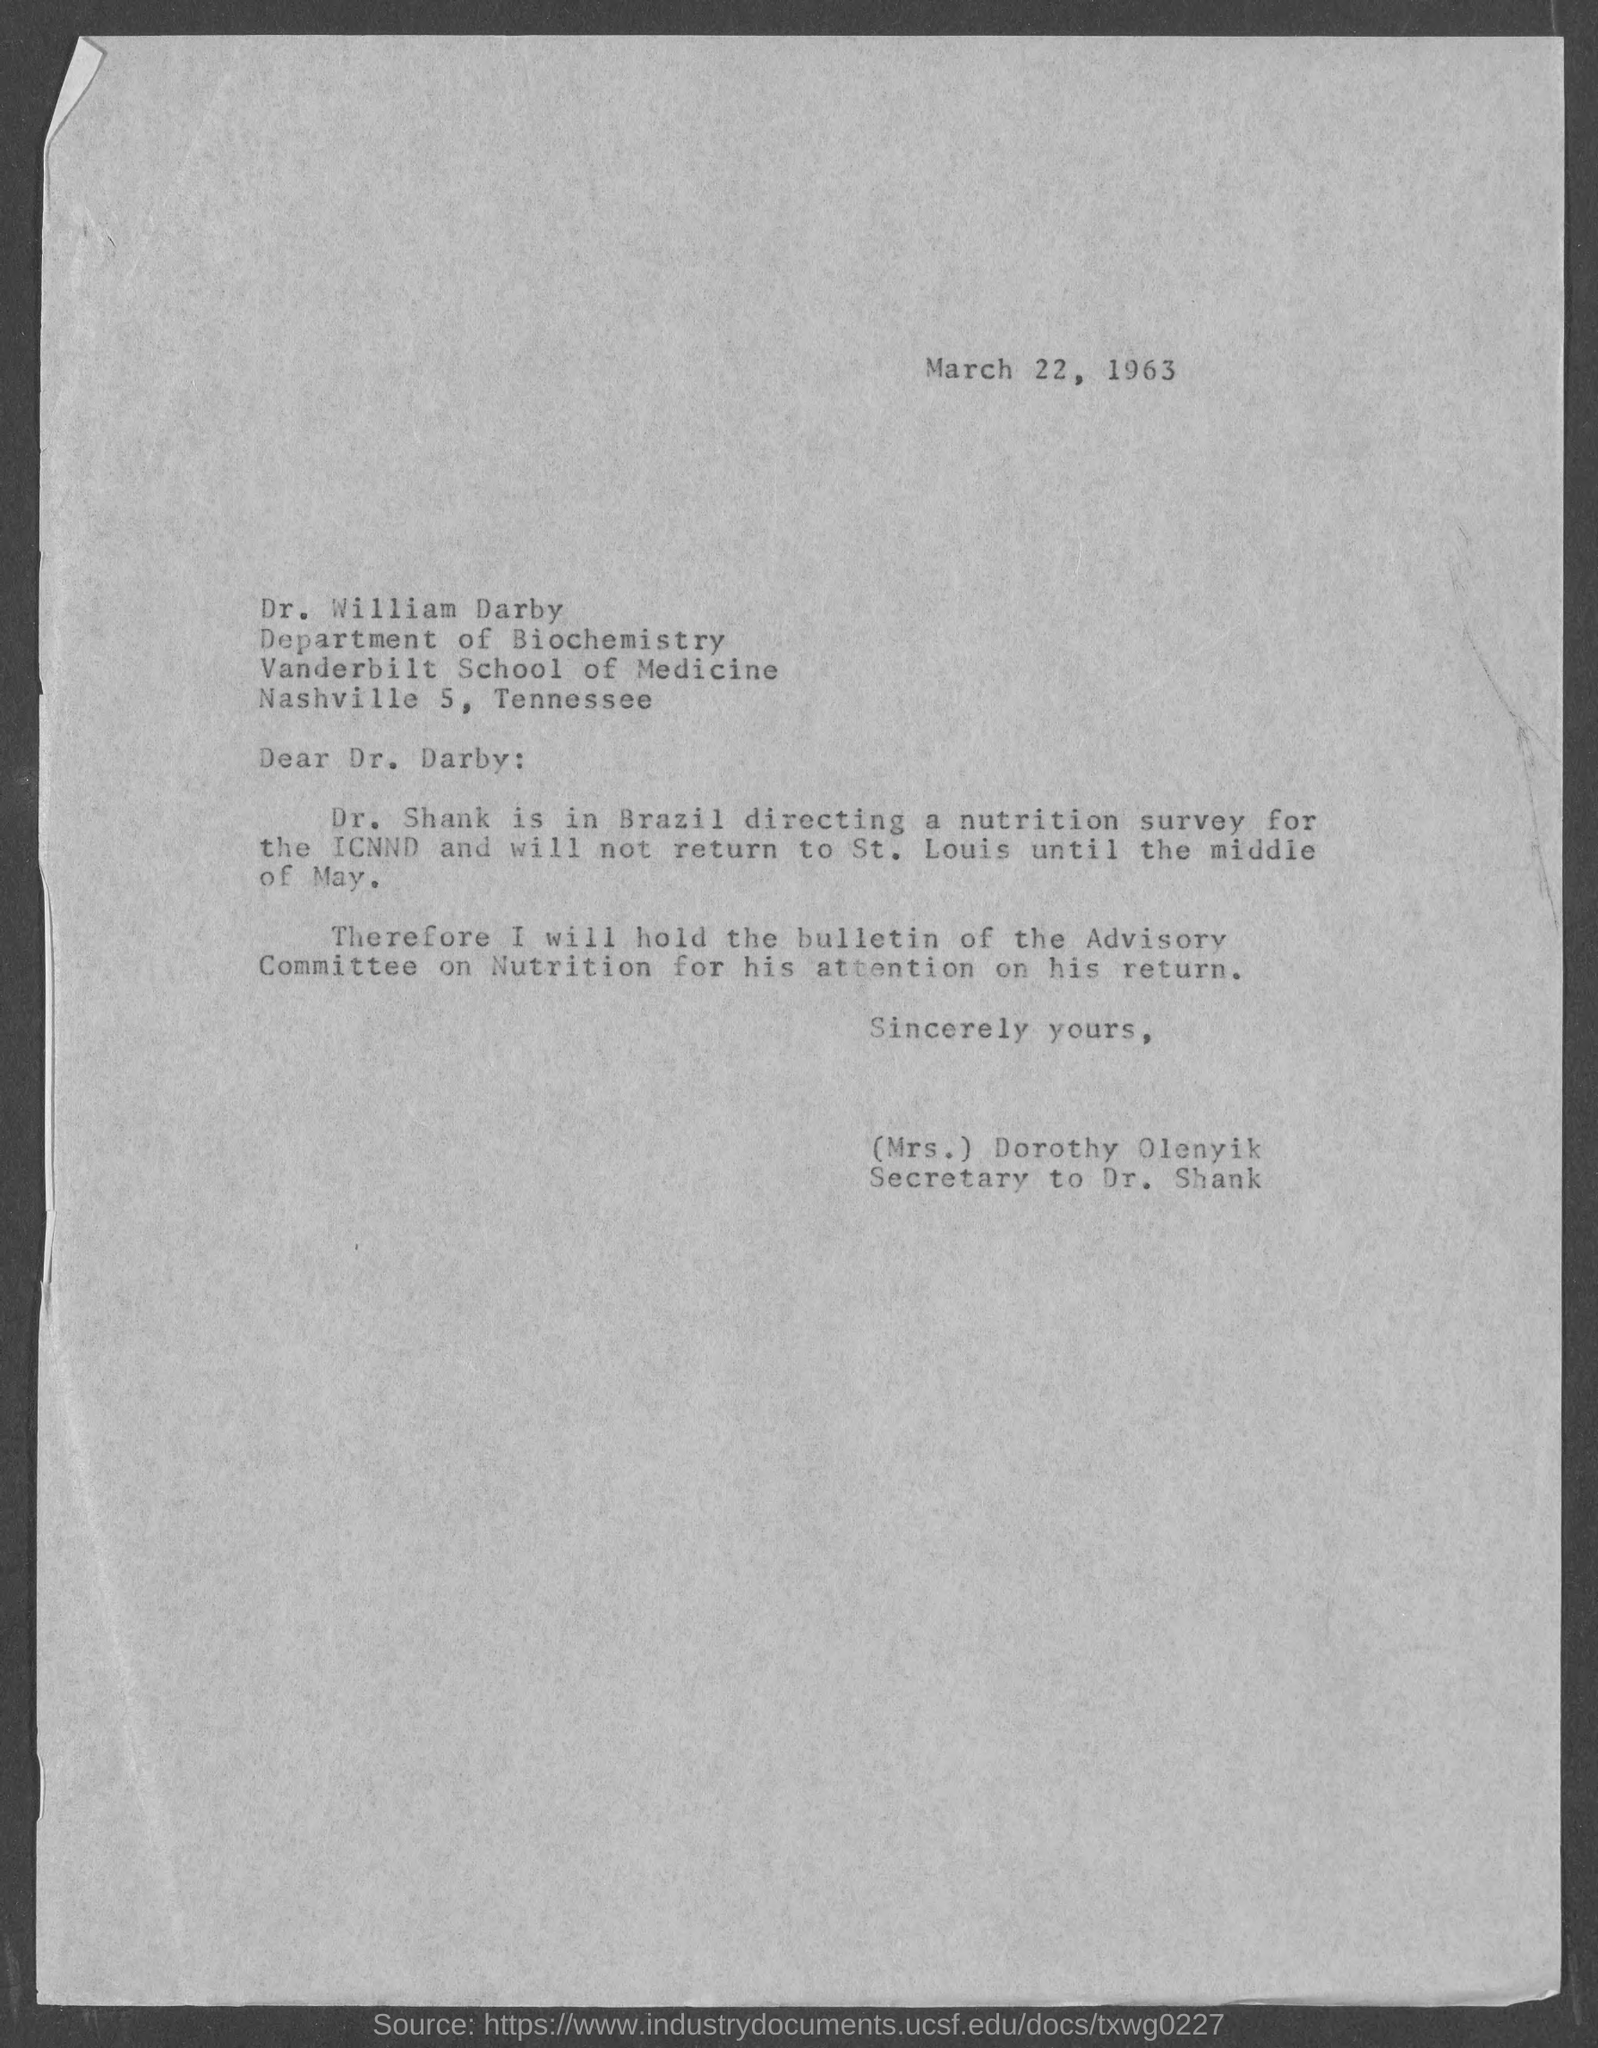What is the date on the letter?
Provide a short and direct response. March 22, 1963. To whom is this letter addressed to?
Your answer should be very brief. Dr. william darby. Who is this letter from?
Your answer should be compact. (Mrs.) Dorothy Olenyik. Where is Dr. Shank?
Your answer should be very brief. In brazil. 